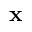Convert formula to latex. <formula><loc_0><loc_0><loc_500><loc_500>x</formula> 